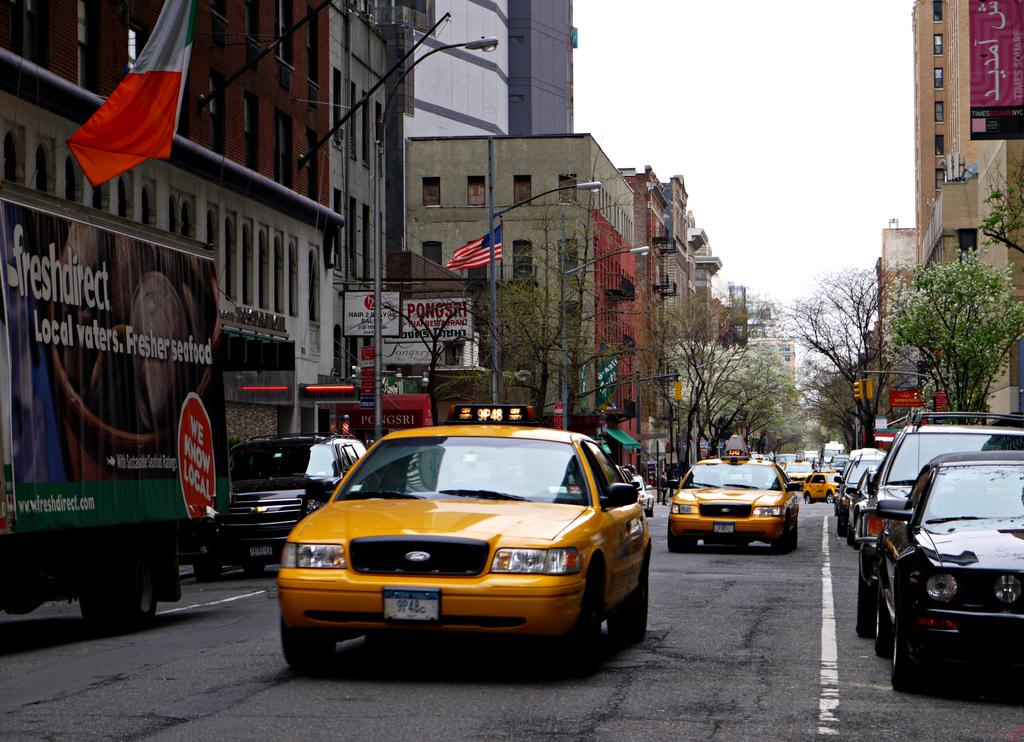<image>
Render a clear and concise summary of the photo. A busy street has many vehicles on it, including a truck passing by that advertises fresher seafood. 